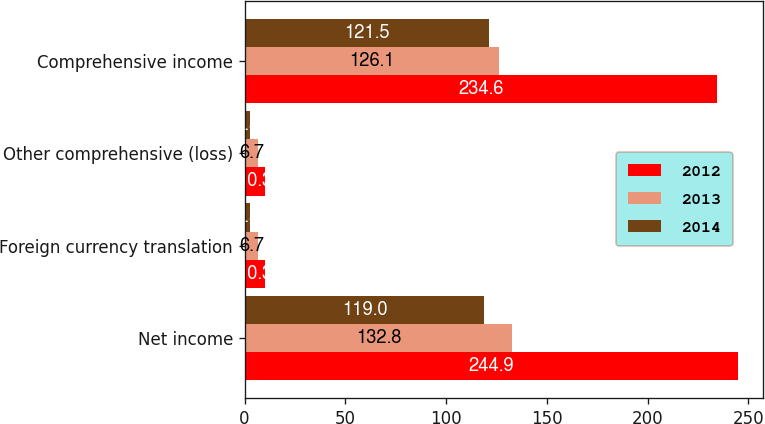Convert chart. <chart><loc_0><loc_0><loc_500><loc_500><stacked_bar_chart><ecel><fcel>Net income<fcel>Foreign currency translation<fcel>Other comprehensive (loss)<fcel>Comprehensive income<nl><fcel>2012<fcel>244.9<fcel>10.3<fcel>10.3<fcel>234.6<nl><fcel>2013<fcel>132.8<fcel>6.7<fcel>6.7<fcel>126.1<nl><fcel>2014<fcel>119<fcel>2.5<fcel>2.5<fcel>121.5<nl></chart> 